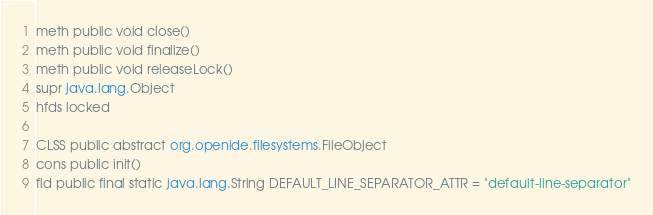Convert code to text. <code><loc_0><loc_0><loc_500><loc_500><_SML_>meth public void close()
meth public void finalize()
meth public void releaseLock()
supr java.lang.Object
hfds locked

CLSS public abstract org.openide.filesystems.FileObject
cons public init()
fld public final static java.lang.String DEFAULT_LINE_SEPARATOR_ATTR = "default-line-separator"</code> 